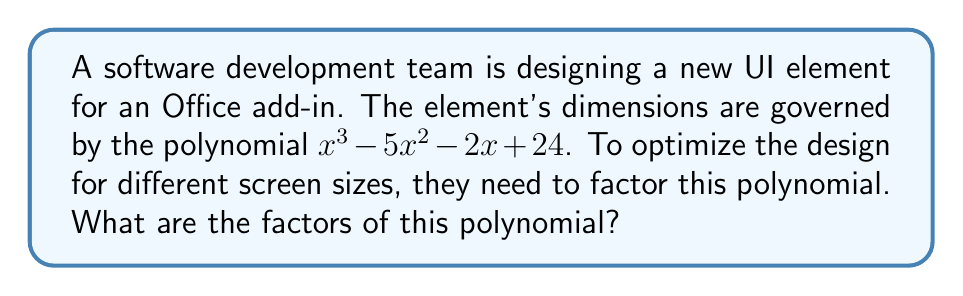Teach me how to tackle this problem. Let's approach this step-by-step:

1) First, we'll try to find a rational root using the rational root theorem. The possible rational roots are the factors of the constant term, 24: ±1, ±2, ±3, ±4, ±6, ±8, ±12, ±24.

2) Testing these values, we find that x = 4 is a root.

3) Now we can factor out (x - 4):

   $x^3 - 5x^2 - 2x + 24 = (x - 4)(x^2 + ax + b)$

4) Expanding the right side:

   $x^3 + ax^2 + bx - 4x^2 - 4ax - 4b$

5) Comparing coefficients with the original polynomial:

   $a - 4 = -5$
   $b - 4a = -2$
   $-4b = 24$

6) From the first equation: $a = -1$
   From the third equation: $b = -6$

7) We can verify these satisfy the second equation: $-6 - 4(-1) = -2$

8) Now we have: $x^3 - 5x^2 - 2x + 24 = (x - 4)(x^2 - x - 6)$

9) The quadratic factor can be further factored:

   $x^2 - x - 6 = (x - 3)(x + 2)$

10) Therefore, the complete factorization is:

    $x^3 - 5x^2 - 2x + 24 = (x - 4)(x - 3)(x + 2)$
Answer: $(x - 4)(x - 3)(x + 2)$ 